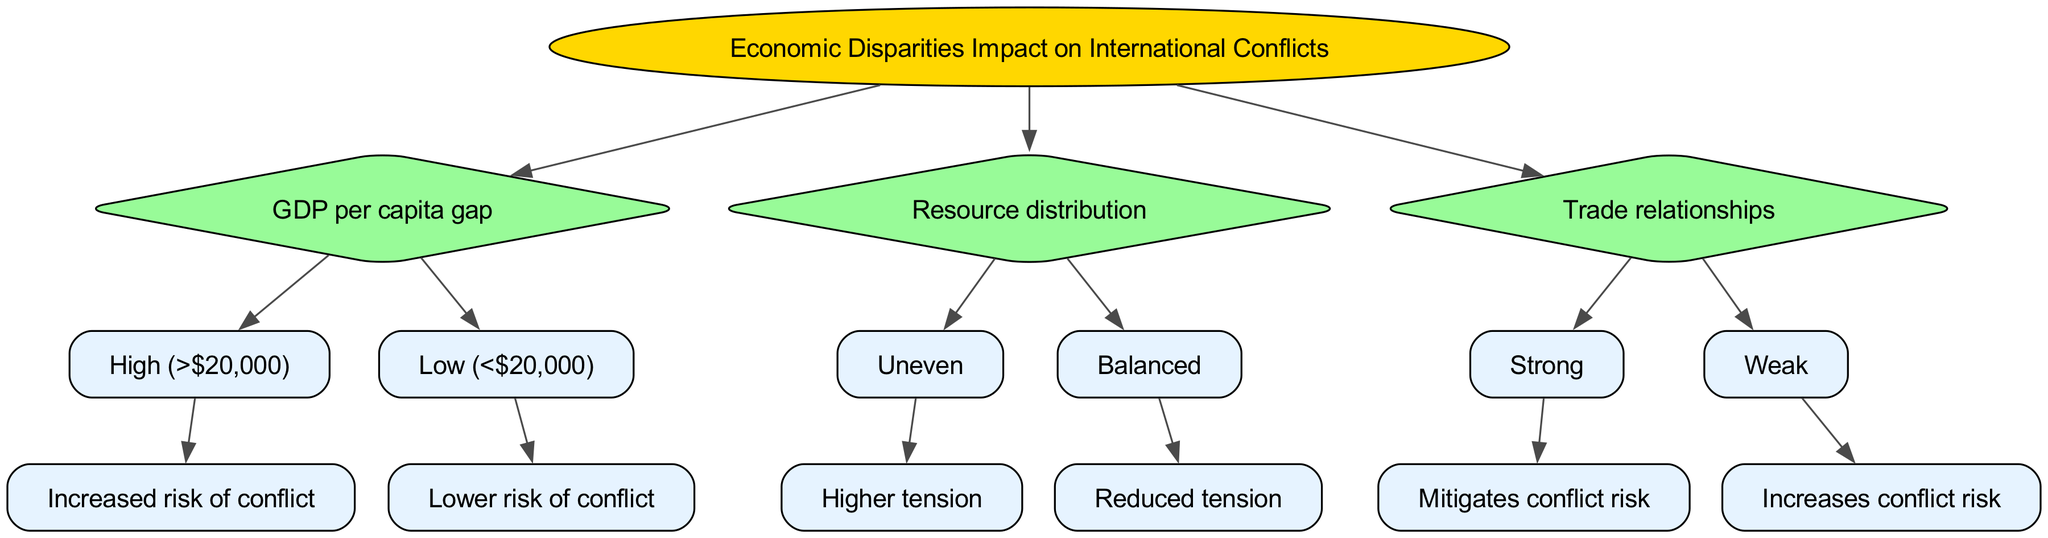What is the root of the decision tree? The root of the decision tree is indicated as the starting point and is labeled "Economic Disparities Impact on International Conflicts." This is the initial node from which all other nodes branch out.
Answer: Economic Disparities Impact on International Conflicts How many main nodes are there in the decision tree? The decision tree consists of three main nodes: GDP per capita gap, Resource distribution, and Trade relationships. These nodes are directly connected to the root node.
Answer: 3 What is the outcome if the GDP per capita gap is high? According to the tree, if the GDP per capita gap is high, it leads to "Increased risk of conflict." This outcome directly follows from the high GDP node.
Answer: Increased risk of conflict What happens when resource distribution is balanced? The decision tree illustrates that if the resource distribution is balanced, it results in "Reduced tension." This conclusion follows from the balanced resource allocation node.
Answer: Reduced tension What is the effect of strong trade relationships? The diagram shows that strong trade relationships "Mitigates conflict risk." This is the outcome associated with the node that deals with strong trade relationships.
Answer: Mitigates conflict risk What impact does a weak trade relationship have? The decision tree indicates that if the trade relationship is weak, it "Increases conflict risk." This outcome is derived from the corresponding weaker trade node.
Answer: Increases conflict risk Which node leads to "Higher tension"? The node that leads to "Higher tension" is "Uneven" under the resource distribution category. This node shows that uneven distribution intensifies tensions.
Answer: Uneven What is the consequence of a low GDP per capita gap? According to the tree, a low GDP per capita gap results in "Lower risk of conflict." This outcome is based on the low GDP node.
Answer: Lower risk of conflict Which path leads to "Higher tension" in the decision tree? The path that leads to "Higher tension" starts from the root, proceeds to the resource distribution node, and then to the uneven node. This reflects tensions arising from resource inequality.
Answer: Root → Resource distribution → Uneven 